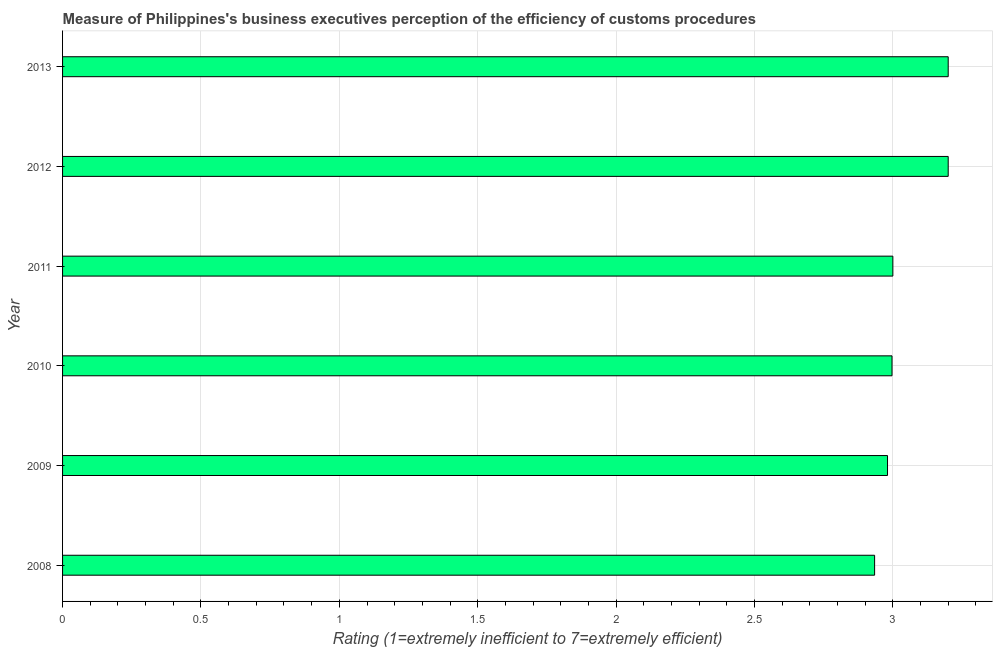What is the title of the graph?
Your response must be concise. Measure of Philippines's business executives perception of the efficiency of customs procedures. What is the label or title of the X-axis?
Ensure brevity in your answer.  Rating (1=extremely inefficient to 7=extremely efficient). What is the label or title of the Y-axis?
Ensure brevity in your answer.  Year. What is the rating measuring burden of customs procedure in 2011?
Your response must be concise. 3. Across all years, what is the minimum rating measuring burden of customs procedure?
Offer a very short reply. 2.93. What is the sum of the rating measuring burden of customs procedure?
Offer a terse response. 18.31. What is the average rating measuring burden of customs procedure per year?
Make the answer very short. 3.05. What is the median rating measuring burden of customs procedure?
Your answer should be compact. 3. In how many years, is the rating measuring burden of customs procedure greater than 1.1 ?
Provide a succinct answer. 6. What is the ratio of the rating measuring burden of customs procedure in 2009 to that in 2010?
Give a very brief answer. 0.99. Is the difference between the rating measuring burden of customs procedure in 2009 and 2012 greater than the difference between any two years?
Offer a very short reply. No. What is the difference between the highest and the lowest rating measuring burden of customs procedure?
Provide a succinct answer. 0.27. In how many years, is the rating measuring burden of customs procedure greater than the average rating measuring burden of customs procedure taken over all years?
Offer a very short reply. 2. How many bars are there?
Ensure brevity in your answer.  6. Are all the bars in the graph horizontal?
Offer a very short reply. Yes. What is the difference between two consecutive major ticks on the X-axis?
Ensure brevity in your answer.  0.5. Are the values on the major ticks of X-axis written in scientific E-notation?
Provide a succinct answer. No. What is the Rating (1=extremely inefficient to 7=extremely efficient) of 2008?
Offer a terse response. 2.93. What is the Rating (1=extremely inefficient to 7=extremely efficient) in 2009?
Provide a short and direct response. 2.98. What is the Rating (1=extremely inefficient to 7=extremely efficient) in 2010?
Your response must be concise. 3. What is the Rating (1=extremely inefficient to 7=extremely efficient) of 2011?
Keep it short and to the point. 3. What is the Rating (1=extremely inefficient to 7=extremely efficient) of 2012?
Your answer should be compact. 3.2. What is the Rating (1=extremely inefficient to 7=extremely efficient) in 2013?
Ensure brevity in your answer.  3.2. What is the difference between the Rating (1=extremely inefficient to 7=extremely efficient) in 2008 and 2009?
Make the answer very short. -0.05. What is the difference between the Rating (1=extremely inefficient to 7=extremely efficient) in 2008 and 2010?
Your response must be concise. -0.06. What is the difference between the Rating (1=extremely inefficient to 7=extremely efficient) in 2008 and 2011?
Provide a short and direct response. -0.07. What is the difference between the Rating (1=extremely inefficient to 7=extremely efficient) in 2008 and 2012?
Offer a terse response. -0.27. What is the difference between the Rating (1=extremely inefficient to 7=extremely efficient) in 2008 and 2013?
Provide a short and direct response. -0.27. What is the difference between the Rating (1=extremely inefficient to 7=extremely efficient) in 2009 and 2010?
Your answer should be compact. -0.02. What is the difference between the Rating (1=extremely inefficient to 7=extremely efficient) in 2009 and 2011?
Your answer should be very brief. -0.02. What is the difference between the Rating (1=extremely inefficient to 7=extremely efficient) in 2009 and 2012?
Your answer should be compact. -0.22. What is the difference between the Rating (1=extremely inefficient to 7=extremely efficient) in 2009 and 2013?
Your answer should be compact. -0.22. What is the difference between the Rating (1=extremely inefficient to 7=extremely efficient) in 2010 and 2011?
Provide a short and direct response. -0. What is the difference between the Rating (1=extremely inefficient to 7=extremely efficient) in 2010 and 2012?
Your response must be concise. -0.2. What is the difference between the Rating (1=extremely inefficient to 7=extremely efficient) in 2010 and 2013?
Your answer should be very brief. -0.2. What is the difference between the Rating (1=extremely inefficient to 7=extremely efficient) in 2011 and 2012?
Make the answer very short. -0.2. What is the ratio of the Rating (1=extremely inefficient to 7=extremely efficient) in 2008 to that in 2009?
Your answer should be very brief. 0.98. What is the ratio of the Rating (1=extremely inefficient to 7=extremely efficient) in 2008 to that in 2011?
Your response must be concise. 0.98. What is the ratio of the Rating (1=extremely inefficient to 7=extremely efficient) in 2008 to that in 2012?
Your response must be concise. 0.92. What is the ratio of the Rating (1=extremely inefficient to 7=extremely efficient) in 2008 to that in 2013?
Provide a succinct answer. 0.92. What is the ratio of the Rating (1=extremely inefficient to 7=extremely efficient) in 2009 to that in 2010?
Ensure brevity in your answer.  0.99. What is the ratio of the Rating (1=extremely inefficient to 7=extremely efficient) in 2009 to that in 2012?
Ensure brevity in your answer.  0.93. What is the ratio of the Rating (1=extremely inefficient to 7=extremely efficient) in 2009 to that in 2013?
Offer a terse response. 0.93. What is the ratio of the Rating (1=extremely inefficient to 7=extremely efficient) in 2010 to that in 2011?
Your answer should be very brief. 1. What is the ratio of the Rating (1=extremely inefficient to 7=extremely efficient) in 2010 to that in 2012?
Your answer should be very brief. 0.94. What is the ratio of the Rating (1=extremely inefficient to 7=extremely efficient) in 2010 to that in 2013?
Your response must be concise. 0.94. What is the ratio of the Rating (1=extremely inefficient to 7=extremely efficient) in 2011 to that in 2012?
Offer a very short reply. 0.94. What is the ratio of the Rating (1=extremely inefficient to 7=extremely efficient) in 2011 to that in 2013?
Offer a terse response. 0.94. What is the ratio of the Rating (1=extremely inefficient to 7=extremely efficient) in 2012 to that in 2013?
Provide a short and direct response. 1. 